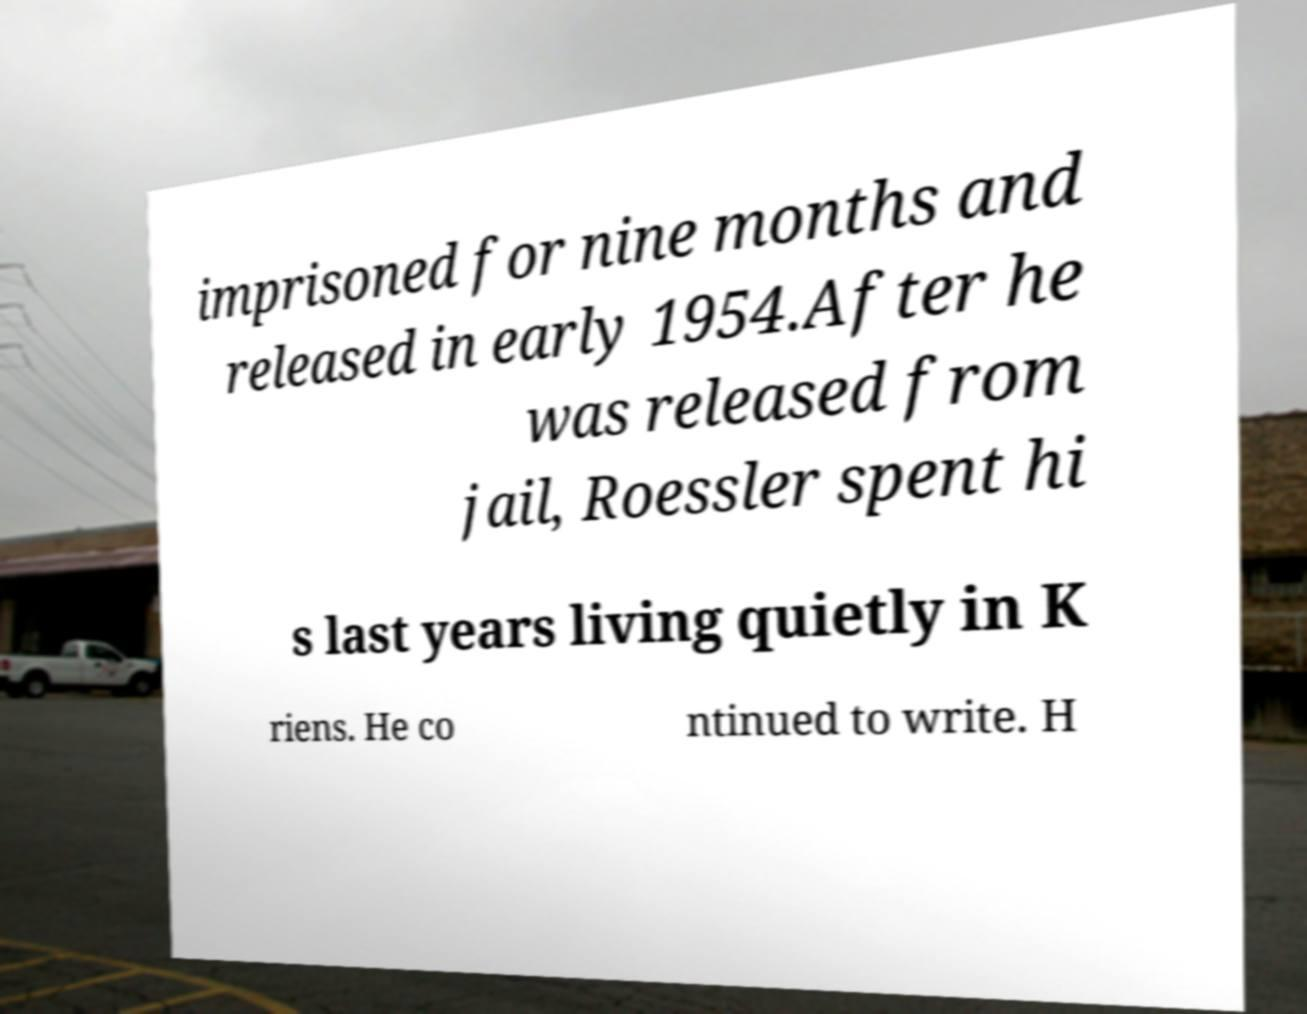There's text embedded in this image that I need extracted. Can you transcribe it verbatim? imprisoned for nine months and released in early 1954.After he was released from jail, Roessler spent hi s last years living quietly in K riens. He co ntinued to write. H 